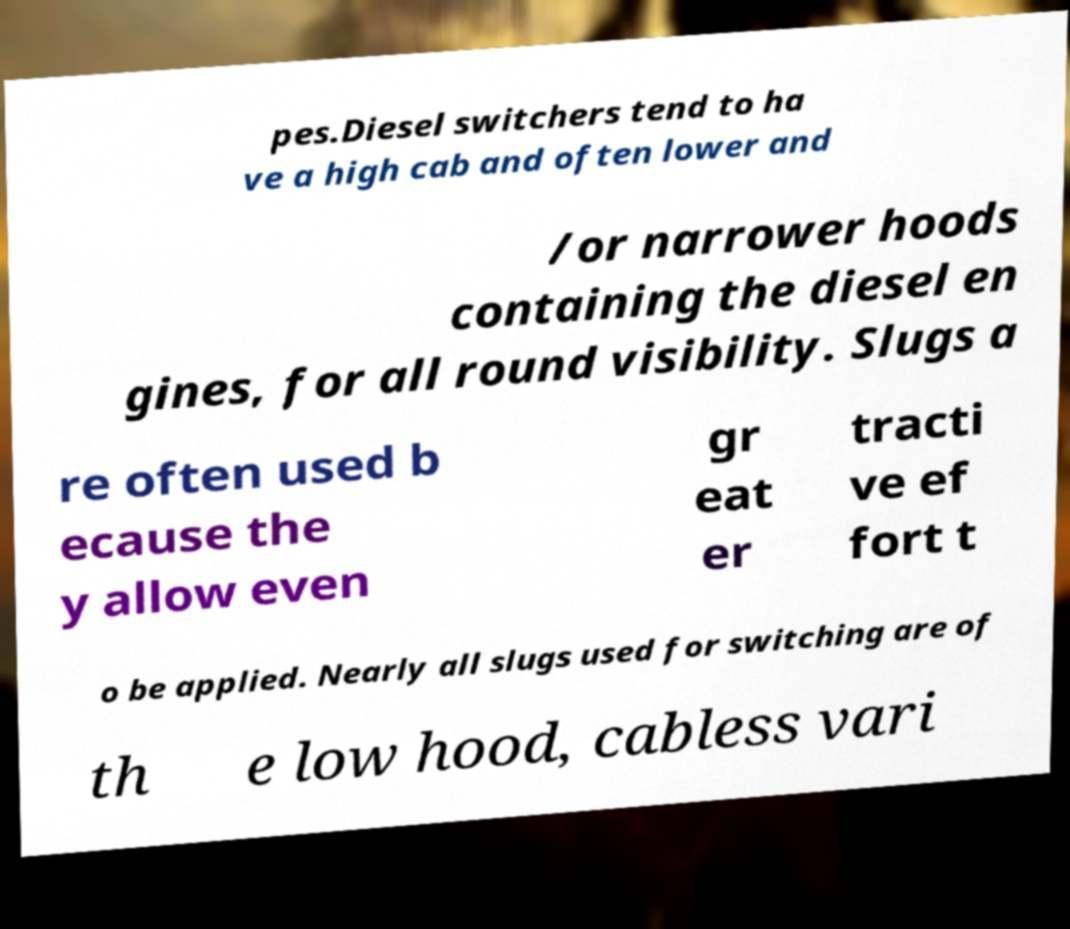Can you read and provide the text displayed in the image?This photo seems to have some interesting text. Can you extract and type it out for me? pes.Diesel switchers tend to ha ve a high cab and often lower and /or narrower hoods containing the diesel en gines, for all round visibility. Slugs a re often used b ecause the y allow even gr eat er tracti ve ef fort t o be applied. Nearly all slugs used for switching are of th e low hood, cabless vari 